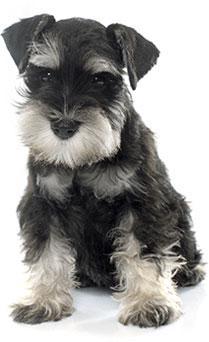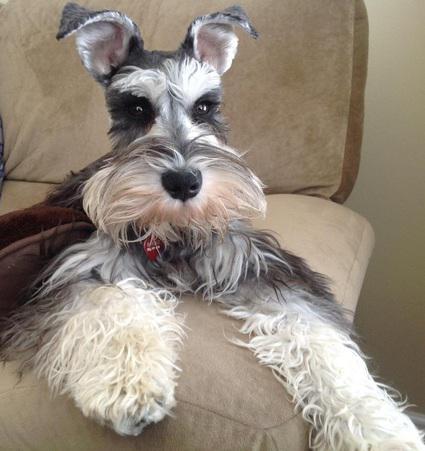The first image is the image on the left, the second image is the image on the right. For the images displayed, is the sentence "there is a dog sitting on a chair indoors" factually correct? Answer yes or no. Yes. The first image is the image on the left, the second image is the image on the right. Given the left and right images, does the statement "Exactly one dog is sitting." hold true? Answer yes or no. Yes. 